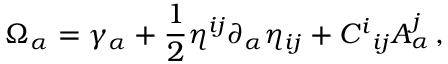Convert formula to latex. <formula><loc_0><loc_0><loc_500><loc_500>\Omega _ { \alpha } = \gamma _ { \alpha } + \frac { 1 } { 2 } \eta ^ { i j } \partial _ { \alpha } \eta _ { i j } + C ^ { i _ { i j } A _ { \alpha } ^ { j } \, ,</formula> 